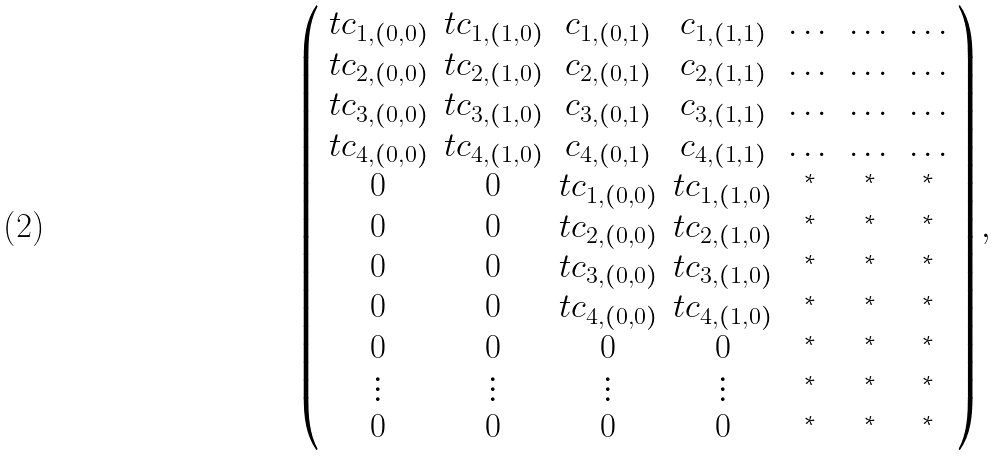<formula> <loc_0><loc_0><loc_500><loc_500>\left ( \begin{array} { c c c c c c c } t c _ { 1 , ( 0 , 0 ) } & t c _ { 1 , ( 1 , 0 ) } & c _ { 1 , ( 0 , 1 ) } & c _ { 1 , ( 1 , 1 ) } & \dots & \dots & \dots \\ t c _ { 2 , ( 0 , 0 ) } & t c _ { 2 , ( 1 , 0 ) } & c _ { 2 , ( 0 , 1 ) } & c _ { 2 , ( 1 , 1 ) } & \dots & \dots & \dots \\ t c _ { 3 , ( 0 , 0 ) } & t c _ { 3 , ( 1 , 0 ) } & c _ { 3 , ( 0 , 1 ) } & c _ { 3 , ( 1 , 1 ) } & \dots & \dots & \dots \\ t c _ { 4 , ( 0 , 0 ) } & t c _ { 4 , ( 1 , 0 ) } & c _ { 4 , ( 0 , 1 ) } & c _ { 4 , ( 1 , 1 ) } & \dots & \dots & \dots \\ 0 & 0 & t c _ { 1 , ( 0 , 0 ) } & t c _ { 1 , ( 1 , 0 ) } & ^ { * } & ^ { * } & ^ { * } \\ 0 & 0 & t c _ { 2 , ( 0 , 0 ) } & t c _ { 2 , ( 1 , 0 ) } & ^ { * } & ^ { * } & ^ { * } \\ 0 & 0 & t c _ { 3 , ( 0 , 0 ) } & t c _ { 3 , ( 1 , 0 ) } & ^ { * } & ^ { * } & ^ { * } \\ 0 & 0 & t c _ { 4 , ( 0 , 0 ) } & t c _ { 4 , ( 1 , 0 ) } & ^ { * } & ^ { * } & ^ { * } \\ 0 & 0 & 0 & 0 & ^ { * } & ^ { * } & ^ { * } \\ \vdots & \vdots & \vdots & \vdots & ^ { * } & ^ { * } & ^ { * } \\ 0 & 0 & 0 & 0 & ^ { * } & ^ { * } & ^ { * } \end{array} \right ) ,</formula> 